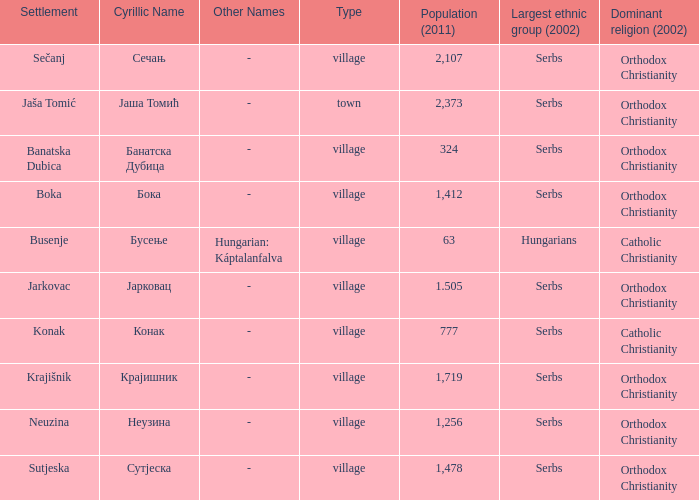The population is 2,107's dominant religion is? Orthodox Christianity. 